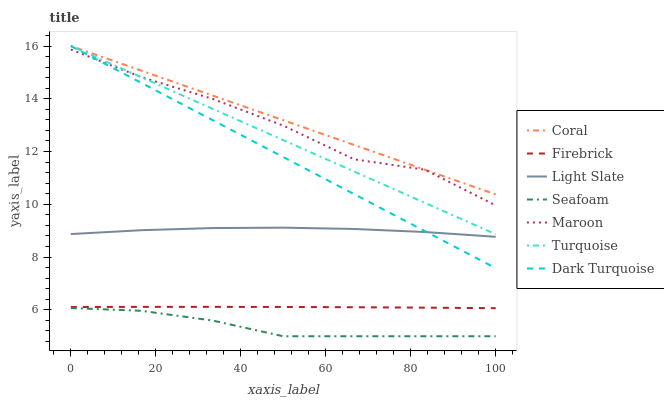Does Seafoam have the minimum area under the curve?
Answer yes or no. Yes. Does Coral have the maximum area under the curve?
Answer yes or no. Yes. Does Light Slate have the minimum area under the curve?
Answer yes or no. No. Does Light Slate have the maximum area under the curve?
Answer yes or no. No. Is Dark Turquoise the smoothest?
Answer yes or no. Yes. Is Maroon the roughest?
Answer yes or no. Yes. Is Light Slate the smoothest?
Answer yes or no. No. Is Light Slate the roughest?
Answer yes or no. No. Does Seafoam have the lowest value?
Answer yes or no. Yes. Does Light Slate have the lowest value?
Answer yes or no. No. Does Coral have the highest value?
Answer yes or no. Yes. Does Light Slate have the highest value?
Answer yes or no. No. Is Seafoam less than Firebrick?
Answer yes or no. Yes. Is Coral greater than Seafoam?
Answer yes or no. Yes. Does Coral intersect Turquoise?
Answer yes or no. Yes. Is Coral less than Turquoise?
Answer yes or no. No. Is Coral greater than Turquoise?
Answer yes or no. No. Does Seafoam intersect Firebrick?
Answer yes or no. No. 